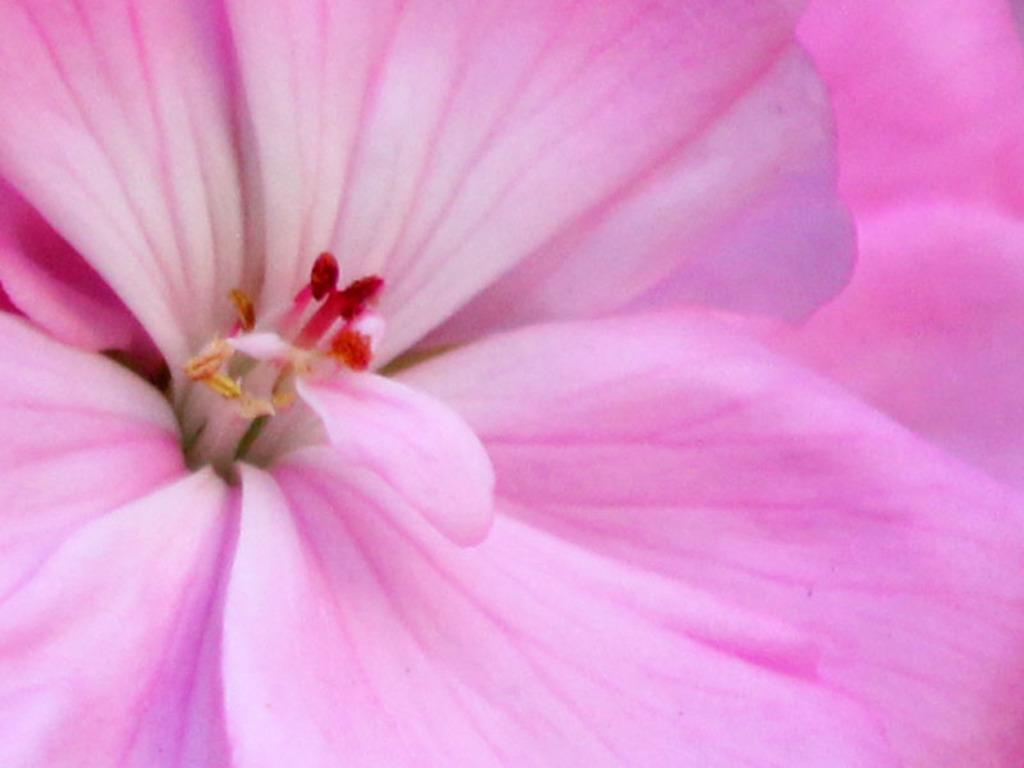What type of plant can be seen in the image? There is a flower in the image. What type of hydrant is visible in the image? There is no hydrant present in the image; it only features a flower. What is the current status of the flower in the image? The provided facts do not mention the current status of the flower, such as whether it is wilting or blooming. 